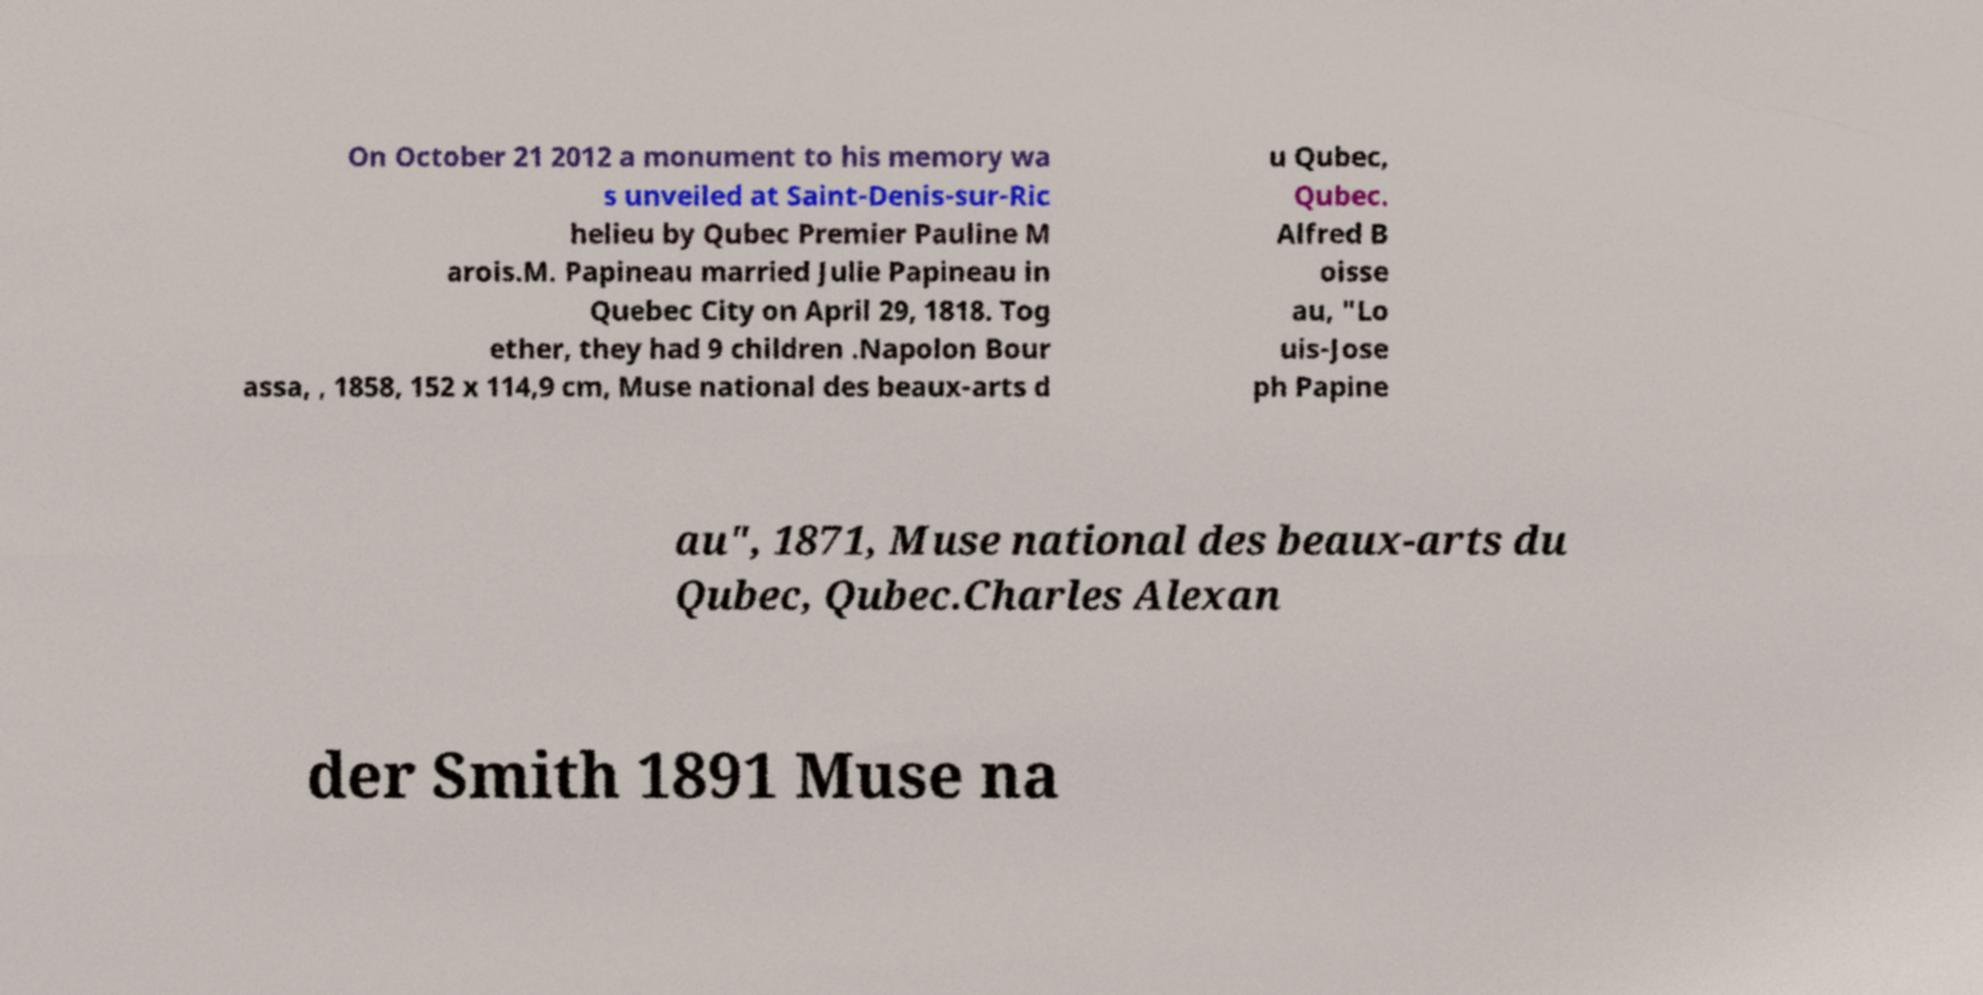Can you accurately transcribe the text from the provided image for me? On October 21 2012 a monument to his memory wa s unveiled at Saint-Denis-sur-Ric helieu by Qubec Premier Pauline M arois.M. Papineau married Julie Papineau in Quebec City on April 29, 1818. Tog ether, they had 9 children .Napolon Bour assa, , 1858, 152 x 114,9 cm, Muse national des beaux-arts d u Qubec, Qubec. Alfred B oisse au, "Lo uis-Jose ph Papine au", 1871, Muse national des beaux-arts du Qubec, Qubec.Charles Alexan der Smith 1891 Muse na 